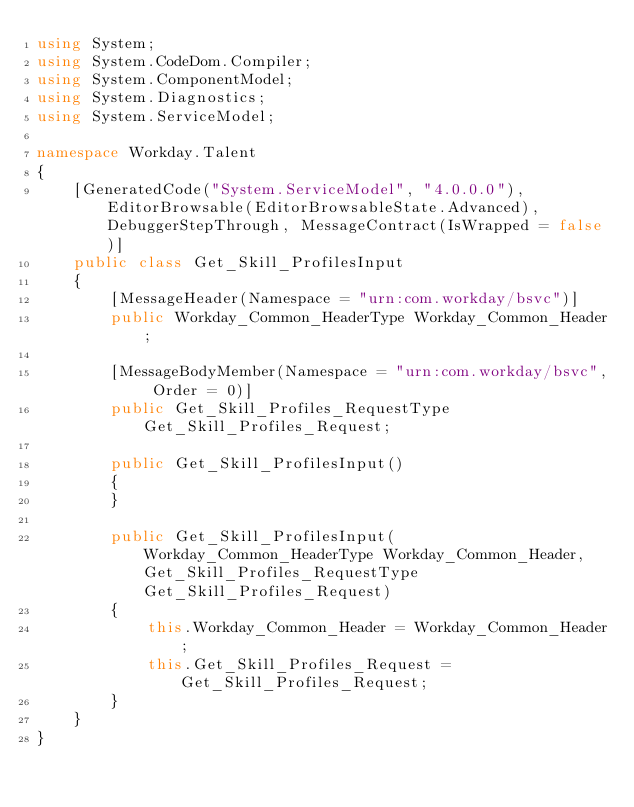<code> <loc_0><loc_0><loc_500><loc_500><_C#_>using System;
using System.CodeDom.Compiler;
using System.ComponentModel;
using System.Diagnostics;
using System.ServiceModel;

namespace Workday.Talent
{
	[GeneratedCode("System.ServiceModel", "4.0.0.0"), EditorBrowsable(EditorBrowsableState.Advanced), DebuggerStepThrough, MessageContract(IsWrapped = false)]
	public class Get_Skill_ProfilesInput
	{
		[MessageHeader(Namespace = "urn:com.workday/bsvc")]
		public Workday_Common_HeaderType Workday_Common_Header;

		[MessageBodyMember(Namespace = "urn:com.workday/bsvc", Order = 0)]
		public Get_Skill_Profiles_RequestType Get_Skill_Profiles_Request;

		public Get_Skill_ProfilesInput()
		{
		}

		public Get_Skill_ProfilesInput(Workday_Common_HeaderType Workday_Common_Header, Get_Skill_Profiles_RequestType Get_Skill_Profiles_Request)
		{
			this.Workday_Common_Header = Workday_Common_Header;
			this.Get_Skill_Profiles_Request = Get_Skill_Profiles_Request;
		}
	}
}
</code> 